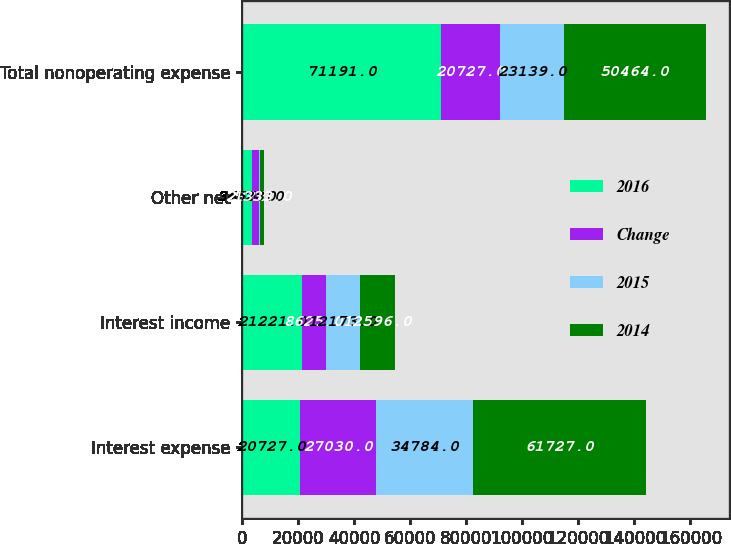<chart> <loc_0><loc_0><loc_500><loc_500><stacked_bar_chart><ecel><fcel>Interest expense<fcel>Interest income<fcel>Other net<fcel>Total nonoperating expense<nl><fcel>2016<fcel>20727<fcel>21221<fcel>3655<fcel>71191<nl><fcel>Change<fcel>27030<fcel>8625<fcel>2322<fcel>20727<nl><fcel>2015<fcel>34784<fcel>12173<fcel>528<fcel>23139<nl><fcel>2014<fcel>61727<fcel>12596<fcel>1333<fcel>50464<nl></chart> 